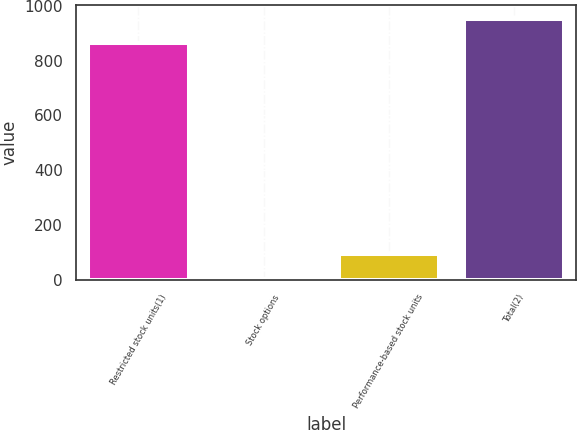<chart> <loc_0><loc_0><loc_500><loc_500><bar_chart><fcel>Restricted stock units(1)<fcel>Stock options<fcel>Performance-based stock units<fcel>Total(2)<nl><fcel>864<fcel>4<fcel>93.3<fcel>953.3<nl></chart> 